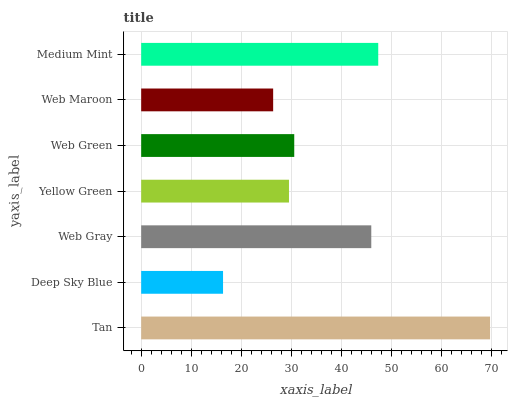Is Deep Sky Blue the minimum?
Answer yes or no. Yes. Is Tan the maximum?
Answer yes or no. Yes. Is Web Gray the minimum?
Answer yes or no. No. Is Web Gray the maximum?
Answer yes or no. No. Is Web Gray greater than Deep Sky Blue?
Answer yes or no. Yes. Is Deep Sky Blue less than Web Gray?
Answer yes or no. Yes. Is Deep Sky Blue greater than Web Gray?
Answer yes or no. No. Is Web Gray less than Deep Sky Blue?
Answer yes or no. No. Is Web Green the high median?
Answer yes or no. Yes. Is Web Green the low median?
Answer yes or no. Yes. Is Medium Mint the high median?
Answer yes or no. No. Is Web Gray the low median?
Answer yes or no. No. 